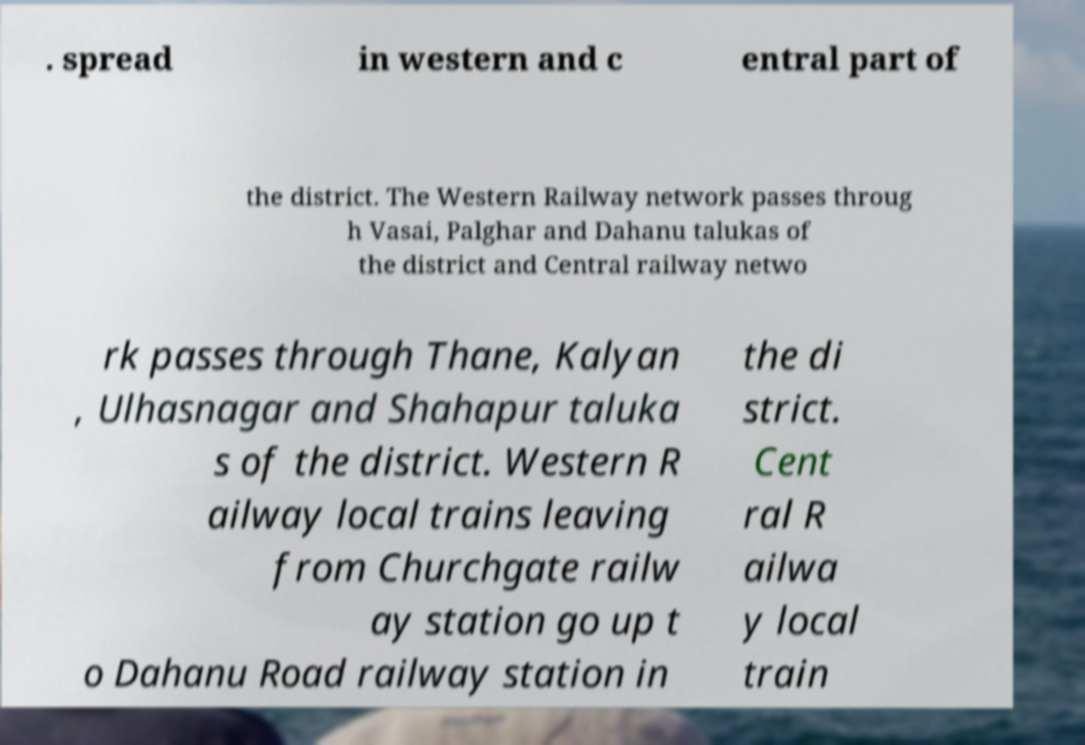Could you assist in decoding the text presented in this image and type it out clearly? . spread in western and c entral part of the district. The Western Railway network passes throug h Vasai, Palghar and Dahanu talukas of the district and Central railway netwo rk passes through Thane, Kalyan , Ulhasnagar and Shahapur taluka s of the district. Western R ailway local trains leaving from Churchgate railw ay station go up t o Dahanu Road railway station in the di strict. Cent ral R ailwa y local train 